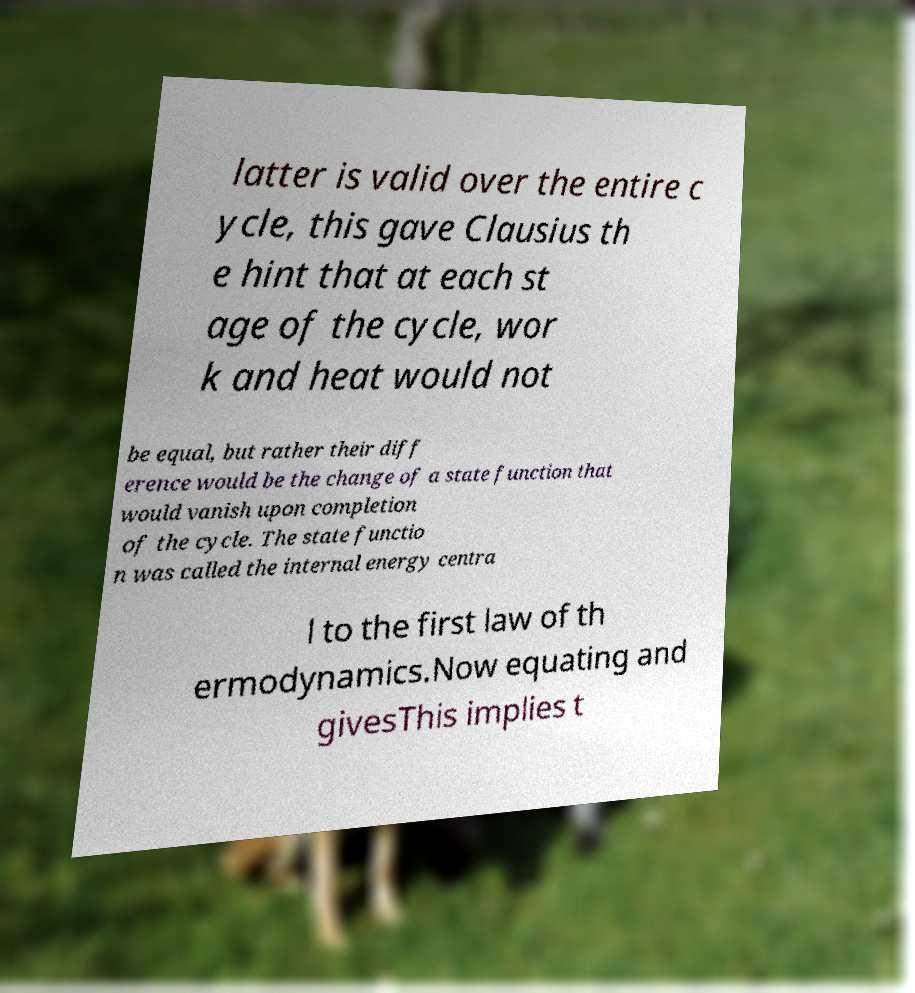There's text embedded in this image that I need extracted. Can you transcribe it verbatim? latter is valid over the entire c ycle, this gave Clausius th e hint that at each st age of the cycle, wor k and heat would not be equal, but rather their diff erence would be the change of a state function that would vanish upon completion of the cycle. The state functio n was called the internal energy centra l to the first law of th ermodynamics.Now equating and givesThis implies t 